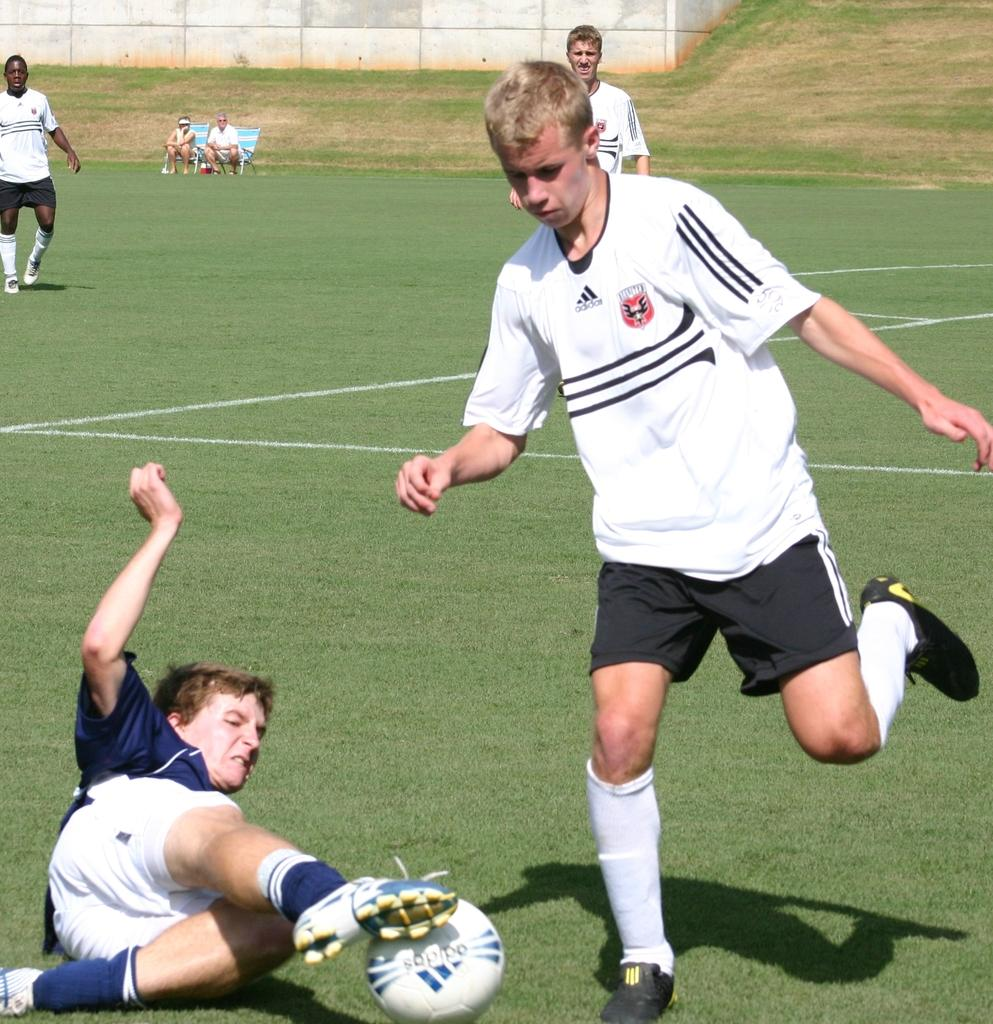How many people are sitting in chairs in the image? There are two people sitting in chairs in the image. What are the two people doing? The two people are watching a football game. Can you describe any specific actions happening in the game? Yes, a player is trying to kick the ball, and another player has slipped on the ball. What type of pail is being used by the players during the game? There is no pail present in the image; it is a football game. What type of voyage are the players embarking on during the game? The players are not embarking on any voyage during the game; they are playing football. 